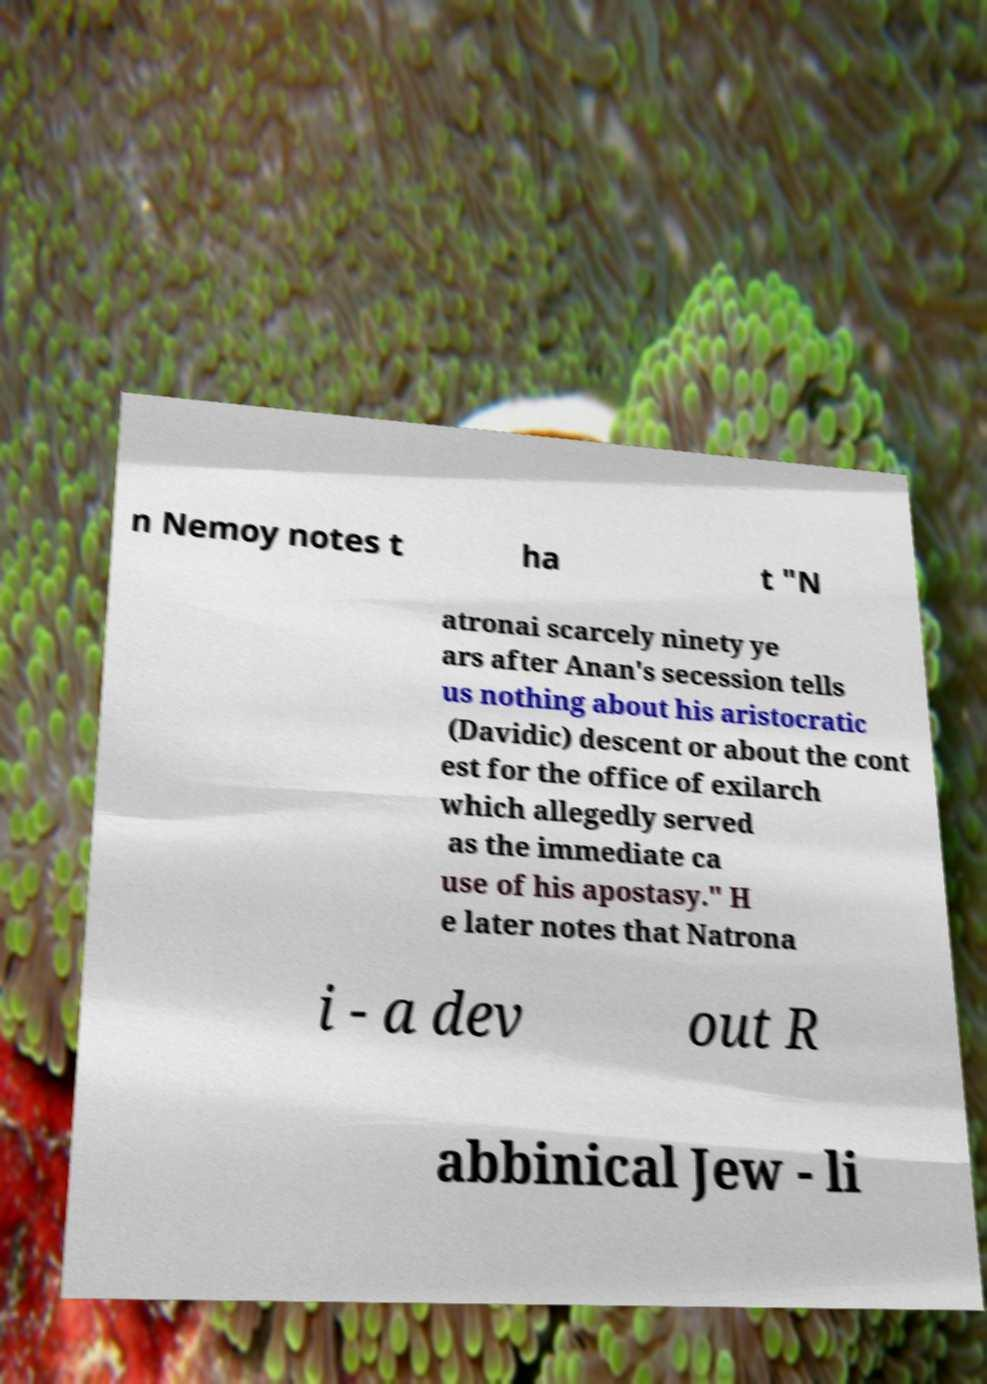Could you assist in decoding the text presented in this image and type it out clearly? n Nemoy notes t ha t "N atronai scarcely ninety ye ars after Anan's secession tells us nothing about his aristocratic (Davidic) descent or about the cont est for the office of exilarch which allegedly served as the immediate ca use of his apostasy." H e later notes that Natrona i - a dev out R abbinical Jew - li 